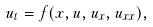Convert formula to latex. <formula><loc_0><loc_0><loc_500><loc_500>u _ { t } = f ( x , u , u _ { x } , u _ { x x } ) ,</formula> 